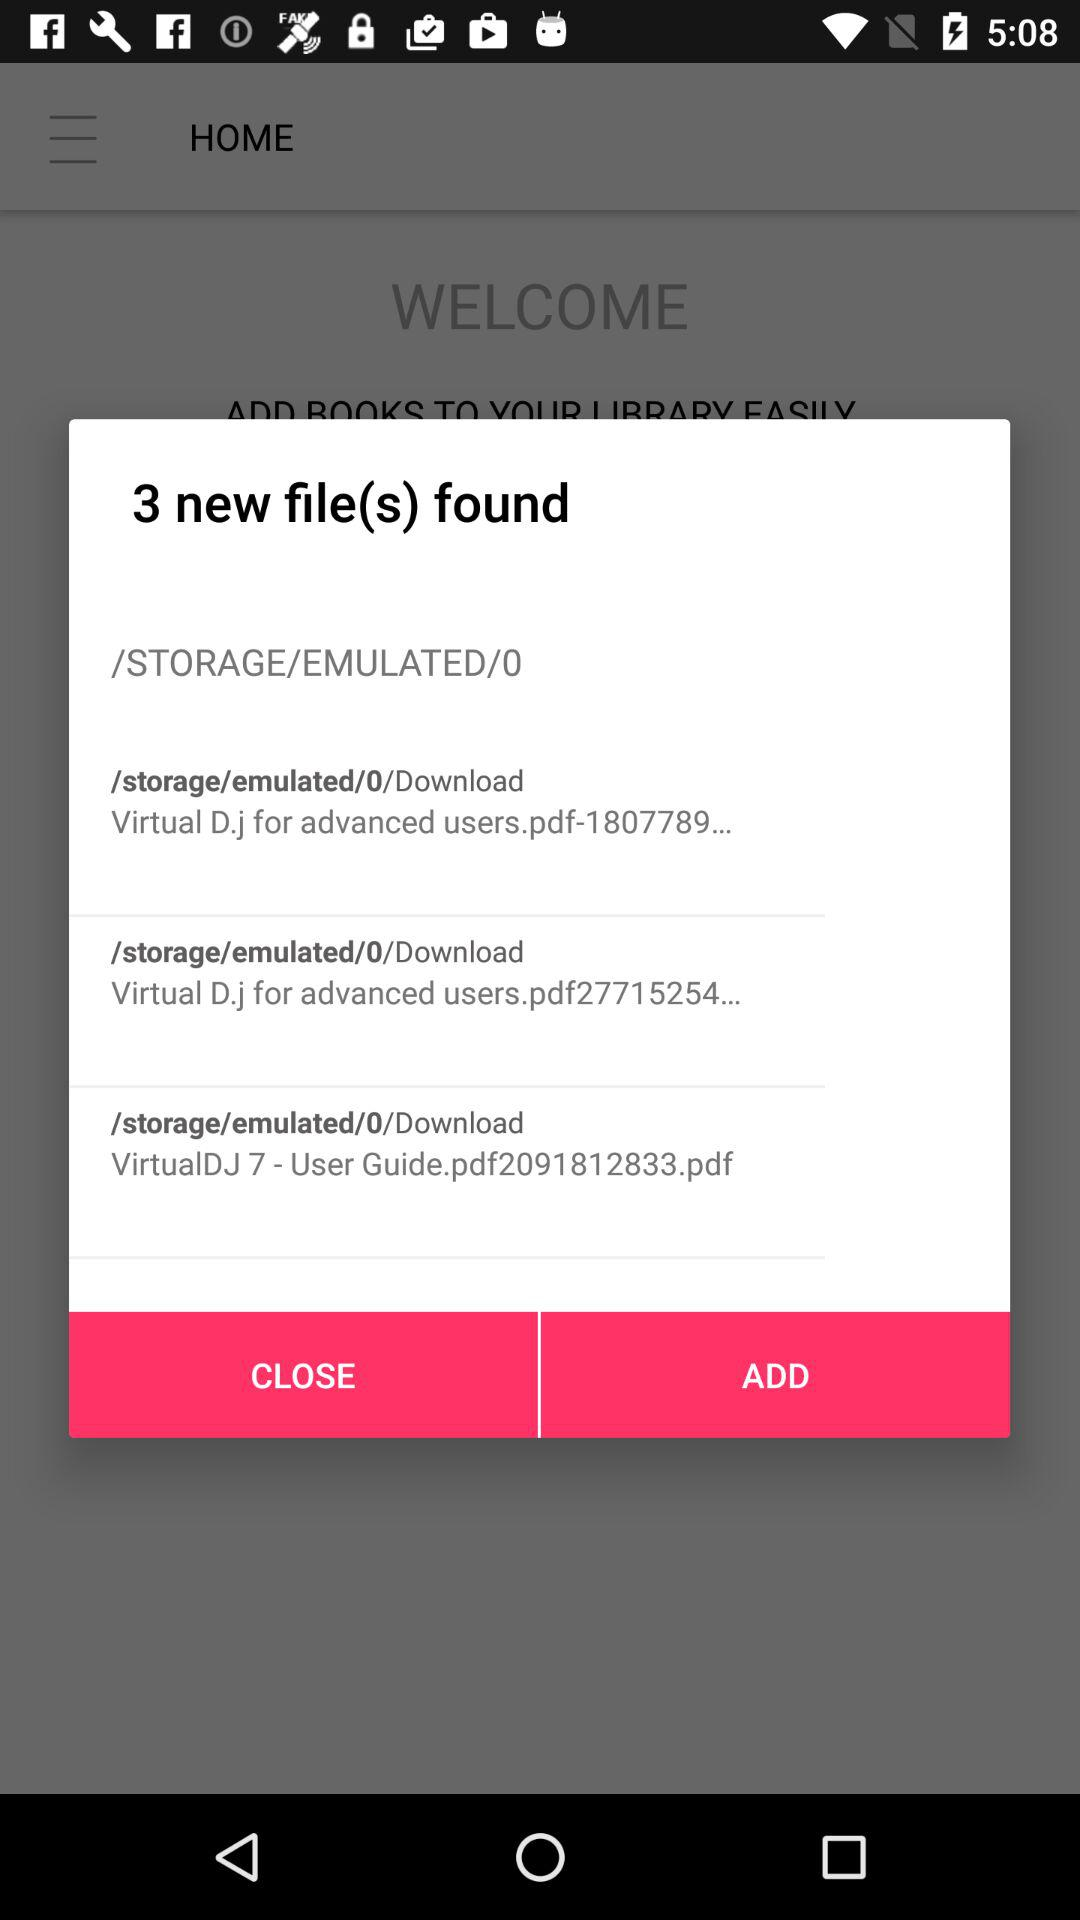How many files are in the Download folder?
Answer the question using a single word or phrase. 3 